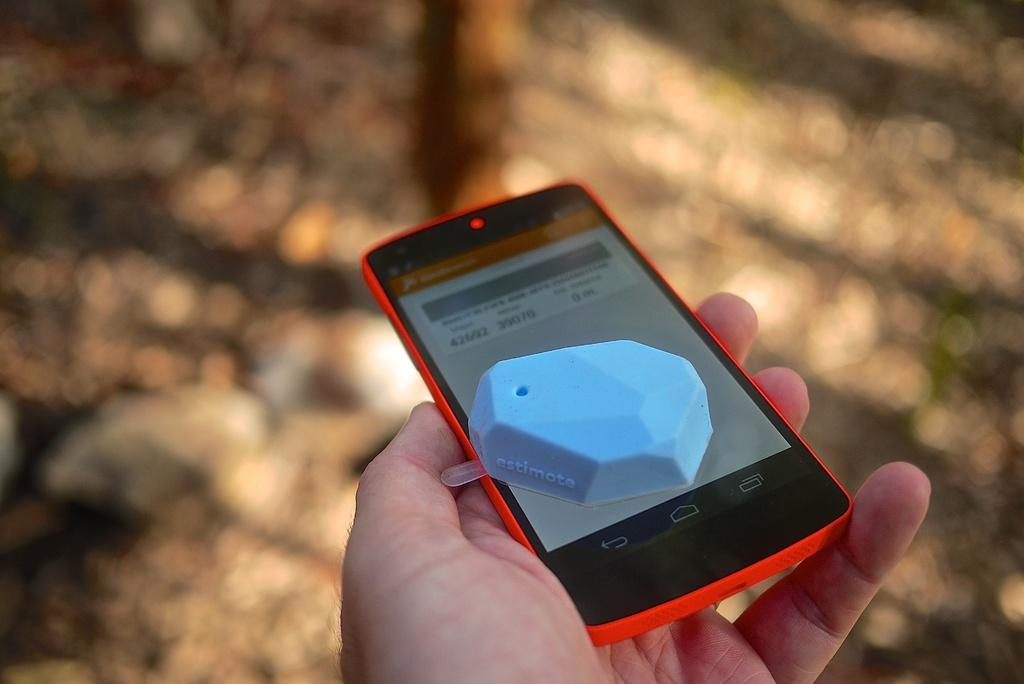<image>
Summarize the visual content of the image. A person is holding a cell phone with a blue object on top that says "estimote" on it. 